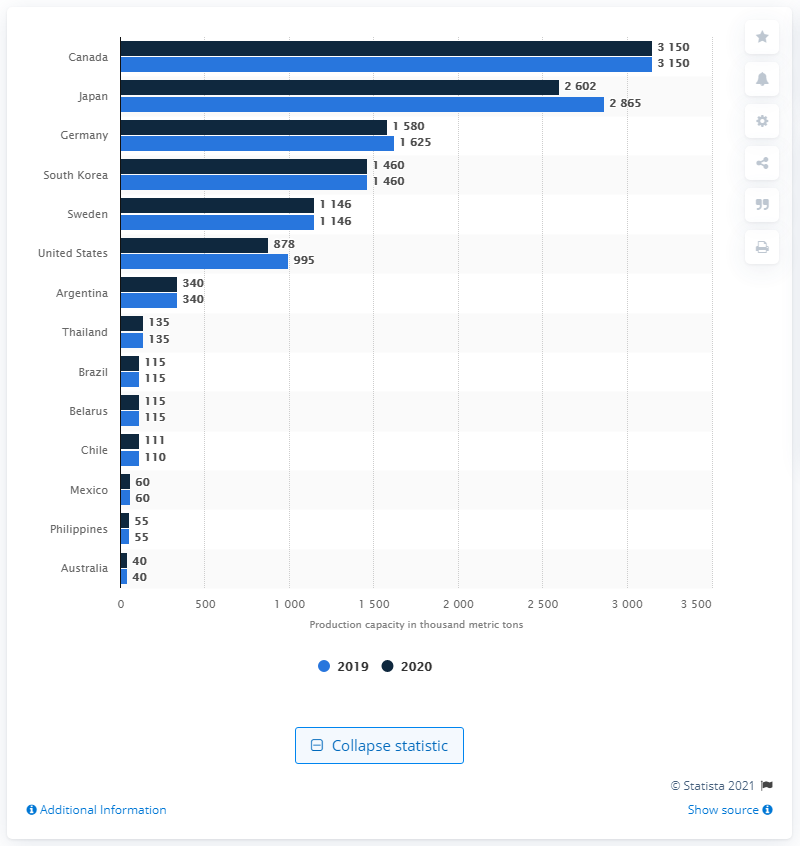Draw attention to some important aspects in this diagram. Japan had the largest production capacity of newsprint in both 2019 and 2020. In 2019 and 2020, Canada had the largest production capacity of newsprint. 